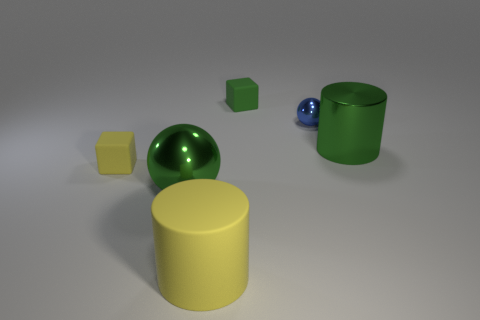What might be the purpose of these objects if they were part of a real-world setting? If these objects were part of a real-world setting, they might serve various purposes. The cylinders could function as containers or storage units, the spheres could be decorative items like ornaments or playthings such as balls, and the cubes could be used for building or as educational tools in activities like sorting or stacking for cognitive development. 